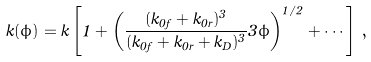Convert formula to latex. <formula><loc_0><loc_0><loc_500><loc_500>k ( \phi ) = k \left [ 1 + \left ( \frac { ( k _ { 0 f } + k _ { 0 r } ) ^ { 3 } } { ( k _ { 0 f } + k _ { 0 r } + k _ { D } ) ^ { 3 } } 3 \phi \right ) ^ { 1 / 2 } + \cdots \right ] \, ,</formula> 